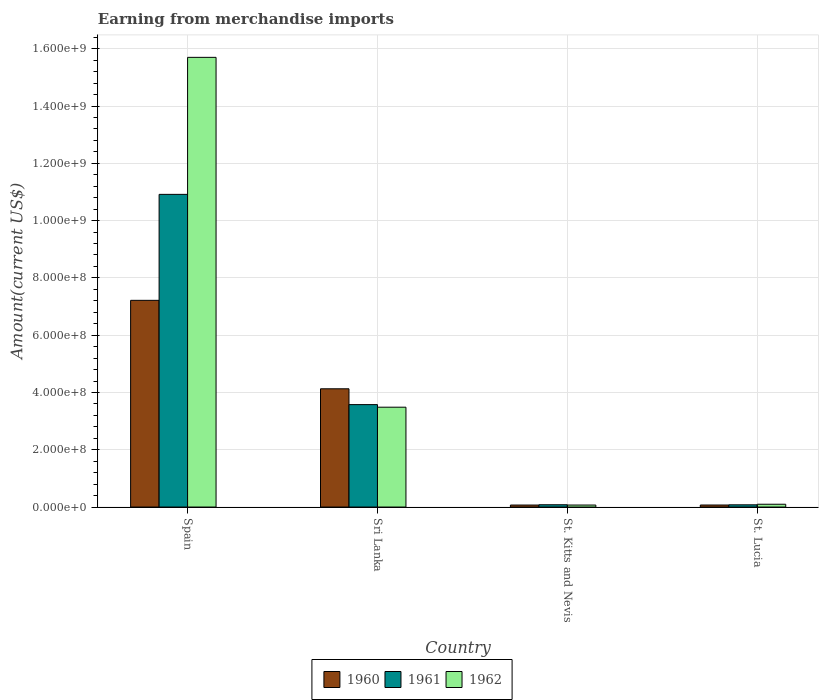How many different coloured bars are there?
Your response must be concise. 3. How many groups of bars are there?
Your answer should be compact. 4. Are the number of bars per tick equal to the number of legend labels?
Your answer should be compact. Yes. Are the number of bars on each tick of the X-axis equal?
Ensure brevity in your answer.  Yes. How many bars are there on the 4th tick from the left?
Your answer should be compact. 3. How many bars are there on the 2nd tick from the right?
Offer a very short reply. 3. What is the label of the 1st group of bars from the left?
Keep it short and to the point. Spain. In how many cases, is the number of bars for a given country not equal to the number of legend labels?
Your answer should be very brief. 0. What is the amount earned from merchandise imports in 1960 in St. Lucia?
Make the answer very short. 7.11e+06. Across all countries, what is the maximum amount earned from merchandise imports in 1960?
Offer a very short reply. 7.22e+08. Across all countries, what is the minimum amount earned from merchandise imports in 1961?
Your answer should be compact. 7.75e+06. In which country was the amount earned from merchandise imports in 1961 minimum?
Your answer should be compact. St. Lucia. What is the total amount earned from merchandise imports in 1961 in the graph?
Make the answer very short. 1.47e+09. What is the difference between the amount earned from merchandise imports in 1960 in Sri Lanka and that in St. Lucia?
Offer a terse response. 4.06e+08. What is the difference between the amount earned from merchandise imports in 1962 in St. Lucia and the amount earned from merchandise imports in 1961 in Sri Lanka?
Keep it short and to the point. -3.48e+08. What is the average amount earned from merchandise imports in 1961 per country?
Give a very brief answer. 3.66e+08. What is the difference between the amount earned from merchandise imports of/in 1961 and amount earned from merchandise imports of/in 1962 in Spain?
Offer a terse response. -4.78e+08. In how many countries, is the amount earned from merchandise imports in 1960 greater than 880000000 US$?
Offer a very short reply. 0. What is the ratio of the amount earned from merchandise imports in 1962 in Spain to that in St. Kitts and Nevis?
Keep it short and to the point. 224.29. Is the amount earned from merchandise imports in 1961 in St. Kitts and Nevis less than that in St. Lucia?
Your response must be concise. No. Is the difference between the amount earned from merchandise imports in 1961 in Sri Lanka and St. Kitts and Nevis greater than the difference between the amount earned from merchandise imports in 1962 in Sri Lanka and St. Kitts and Nevis?
Keep it short and to the point. Yes. What is the difference between the highest and the second highest amount earned from merchandise imports in 1960?
Your response must be concise. 7.15e+08. What is the difference between the highest and the lowest amount earned from merchandise imports in 1962?
Make the answer very short. 1.56e+09. In how many countries, is the amount earned from merchandise imports in 1962 greater than the average amount earned from merchandise imports in 1962 taken over all countries?
Offer a terse response. 1. Is the sum of the amount earned from merchandise imports in 1961 in Spain and Sri Lanka greater than the maximum amount earned from merchandise imports in 1962 across all countries?
Offer a terse response. No. What does the 1st bar from the left in St. Kitts and Nevis represents?
Your answer should be very brief. 1960. Is it the case that in every country, the sum of the amount earned from merchandise imports in 1961 and amount earned from merchandise imports in 1962 is greater than the amount earned from merchandise imports in 1960?
Keep it short and to the point. Yes. How many bars are there?
Your answer should be very brief. 12. How many countries are there in the graph?
Provide a succinct answer. 4. What is the difference between two consecutive major ticks on the Y-axis?
Give a very brief answer. 2.00e+08. Are the values on the major ticks of Y-axis written in scientific E-notation?
Provide a succinct answer. Yes. Does the graph contain any zero values?
Your answer should be compact. No. Where does the legend appear in the graph?
Keep it short and to the point. Bottom center. How many legend labels are there?
Make the answer very short. 3. What is the title of the graph?
Keep it short and to the point. Earning from merchandise imports. What is the label or title of the Y-axis?
Ensure brevity in your answer.  Amount(current US$). What is the Amount(current US$) in 1960 in Spain?
Ensure brevity in your answer.  7.22e+08. What is the Amount(current US$) of 1961 in Spain?
Provide a short and direct response. 1.09e+09. What is the Amount(current US$) in 1962 in Spain?
Your answer should be compact. 1.57e+09. What is the Amount(current US$) in 1960 in Sri Lanka?
Provide a short and direct response. 4.13e+08. What is the Amount(current US$) in 1961 in Sri Lanka?
Your answer should be very brief. 3.58e+08. What is the Amount(current US$) of 1962 in Sri Lanka?
Ensure brevity in your answer.  3.49e+08. What is the Amount(current US$) of 1960 in St. Kitts and Nevis?
Make the answer very short. 7.00e+06. What is the Amount(current US$) in 1962 in St. Kitts and Nevis?
Keep it short and to the point. 7.00e+06. What is the Amount(current US$) of 1960 in St. Lucia?
Provide a short and direct response. 7.11e+06. What is the Amount(current US$) in 1961 in St. Lucia?
Provide a short and direct response. 7.75e+06. What is the Amount(current US$) in 1962 in St. Lucia?
Keep it short and to the point. 9.77e+06. Across all countries, what is the maximum Amount(current US$) of 1960?
Give a very brief answer. 7.22e+08. Across all countries, what is the maximum Amount(current US$) in 1961?
Ensure brevity in your answer.  1.09e+09. Across all countries, what is the maximum Amount(current US$) of 1962?
Make the answer very short. 1.57e+09. Across all countries, what is the minimum Amount(current US$) of 1961?
Keep it short and to the point. 7.75e+06. Across all countries, what is the minimum Amount(current US$) in 1962?
Offer a terse response. 7.00e+06. What is the total Amount(current US$) in 1960 in the graph?
Offer a terse response. 1.15e+09. What is the total Amount(current US$) in 1961 in the graph?
Your answer should be compact. 1.47e+09. What is the total Amount(current US$) in 1962 in the graph?
Offer a terse response. 1.94e+09. What is the difference between the Amount(current US$) in 1960 in Spain and that in Sri Lanka?
Give a very brief answer. 3.09e+08. What is the difference between the Amount(current US$) of 1961 in Spain and that in Sri Lanka?
Provide a short and direct response. 7.34e+08. What is the difference between the Amount(current US$) of 1962 in Spain and that in Sri Lanka?
Your answer should be very brief. 1.22e+09. What is the difference between the Amount(current US$) in 1960 in Spain and that in St. Kitts and Nevis?
Provide a short and direct response. 7.15e+08. What is the difference between the Amount(current US$) of 1961 in Spain and that in St. Kitts and Nevis?
Your answer should be very brief. 1.08e+09. What is the difference between the Amount(current US$) in 1962 in Spain and that in St. Kitts and Nevis?
Provide a short and direct response. 1.56e+09. What is the difference between the Amount(current US$) in 1960 in Spain and that in St. Lucia?
Offer a very short reply. 7.15e+08. What is the difference between the Amount(current US$) in 1961 in Spain and that in St. Lucia?
Provide a succinct answer. 1.08e+09. What is the difference between the Amount(current US$) in 1962 in Spain and that in St. Lucia?
Provide a short and direct response. 1.56e+09. What is the difference between the Amount(current US$) in 1960 in Sri Lanka and that in St. Kitts and Nevis?
Ensure brevity in your answer.  4.06e+08. What is the difference between the Amount(current US$) in 1961 in Sri Lanka and that in St. Kitts and Nevis?
Offer a very short reply. 3.50e+08. What is the difference between the Amount(current US$) of 1962 in Sri Lanka and that in St. Kitts and Nevis?
Offer a very short reply. 3.42e+08. What is the difference between the Amount(current US$) in 1960 in Sri Lanka and that in St. Lucia?
Keep it short and to the point. 4.06e+08. What is the difference between the Amount(current US$) of 1961 in Sri Lanka and that in St. Lucia?
Keep it short and to the point. 3.50e+08. What is the difference between the Amount(current US$) in 1962 in Sri Lanka and that in St. Lucia?
Ensure brevity in your answer.  3.39e+08. What is the difference between the Amount(current US$) of 1960 in St. Kitts and Nevis and that in St. Lucia?
Make the answer very short. -1.07e+05. What is the difference between the Amount(current US$) of 1961 in St. Kitts and Nevis and that in St. Lucia?
Keep it short and to the point. 2.48e+05. What is the difference between the Amount(current US$) in 1962 in St. Kitts and Nevis and that in St. Lucia?
Your answer should be compact. -2.77e+06. What is the difference between the Amount(current US$) of 1960 in Spain and the Amount(current US$) of 1961 in Sri Lanka?
Keep it short and to the point. 3.64e+08. What is the difference between the Amount(current US$) of 1960 in Spain and the Amount(current US$) of 1962 in Sri Lanka?
Keep it short and to the point. 3.73e+08. What is the difference between the Amount(current US$) in 1961 in Spain and the Amount(current US$) in 1962 in Sri Lanka?
Your answer should be very brief. 7.43e+08. What is the difference between the Amount(current US$) of 1960 in Spain and the Amount(current US$) of 1961 in St. Kitts and Nevis?
Keep it short and to the point. 7.14e+08. What is the difference between the Amount(current US$) of 1960 in Spain and the Amount(current US$) of 1962 in St. Kitts and Nevis?
Ensure brevity in your answer.  7.15e+08. What is the difference between the Amount(current US$) of 1961 in Spain and the Amount(current US$) of 1962 in St. Kitts and Nevis?
Give a very brief answer. 1.08e+09. What is the difference between the Amount(current US$) in 1960 in Spain and the Amount(current US$) in 1961 in St. Lucia?
Your answer should be compact. 7.14e+08. What is the difference between the Amount(current US$) of 1960 in Spain and the Amount(current US$) of 1962 in St. Lucia?
Your answer should be compact. 7.12e+08. What is the difference between the Amount(current US$) of 1961 in Spain and the Amount(current US$) of 1962 in St. Lucia?
Provide a succinct answer. 1.08e+09. What is the difference between the Amount(current US$) of 1960 in Sri Lanka and the Amount(current US$) of 1961 in St. Kitts and Nevis?
Provide a short and direct response. 4.05e+08. What is the difference between the Amount(current US$) in 1960 in Sri Lanka and the Amount(current US$) in 1962 in St. Kitts and Nevis?
Offer a very short reply. 4.06e+08. What is the difference between the Amount(current US$) of 1961 in Sri Lanka and the Amount(current US$) of 1962 in St. Kitts and Nevis?
Your response must be concise. 3.51e+08. What is the difference between the Amount(current US$) in 1960 in Sri Lanka and the Amount(current US$) in 1961 in St. Lucia?
Offer a terse response. 4.05e+08. What is the difference between the Amount(current US$) of 1960 in Sri Lanka and the Amount(current US$) of 1962 in St. Lucia?
Provide a succinct answer. 4.03e+08. What is the difference between the Amount(current US$) of 1961 in Sri Lanka and the Amount(current US$) of 1962 in St. Lucia?
Your answer should be compact. 3.48e+08. What is the difference between the Amount(current US$) of 1960 in St. Kitts and Nevis and the Amount(current US$) of 1961 in St. Lucia?
Provide a succinct answer. -7.52e+05. What is the difference between the Amount(current US$) in 1960 in St. Kitts and Nevis and the Amount(current US$) in 1962 in St. Lucia?
Keep it short and to the point. -2.77e+06. What is the difference between the Amount(current US$) of 1961 in St. Kitts and Nevis and the Amount(current US$) of 1962 in St. Lucia?
Provide a succinct answer. -1.77e+06. What is the average Amount(current US$) in 1960 per country?
Your response must be concise. 2.87e+08. What is the average Amount(current US$) in 1961 per country?
Your response must be concise. 3.66e+08. What is the average Amount(current US$) of 1962 per country?
Ensure brevity in your answer.  4.84e+08. What is the difference between the Amount(current US$) in 1960 and Amount(current US$) in 1961 in Spain?
Give a very brief answer. -3.70e+08. What is the difference between the Amount(current US$) in 1960 and Amount(current US$) in 1962 in Spain?
Offer a terse response. -8.48e+08. What is the difference between the Amount(current US$) in 1961 and Amount(current US$) in 1962 in Spain?
Give a very brief answer. -4.78e+08. What is the difference between the Amount(current US$) of 1960 and Amount(current US$) of 1961 in Sri Lanka?
Offer a terse response. 5.52e+07. What is the difference between the Amount(current US$) in 1960 and Amount(current US$) in 1962 in Sri Lanka?
Make the answer very short. 6.43e+07. What is the difference between the Amount(current US$) of 1961 and Amount(current US$) of 1962 in Sri Lanka?
Give a very brief answer. 9.03e+06. What is the difference between the Amount(current US$) of 1961 and Amount(current US$) of 1962 in St. Kitts and Nevis?
Make the answer very short. 1.00e+06. What is the difference between the Amount(current US$) of 1960 and Amount(current US$) of 1961 in St. Lucia?
Make the answer very short. -6.46e+05. What is the difference between the Amount(current US$) in 1960 and Amount(current US$) in 1962 in St. Lucia?
Provide a succinct answer. -2.66e+06. What is the difference between the Amount(current US$) in 1961 and Amount(current US$) in 1962 in St. Lucia?
Give a very brief answer. -2.02e+06. What is the ratio of the Amount(current US$) of 1960 in Spain to that in Sri Lanka?
Ensure brevity in your answer.  1.75. What is the ratio of the Amount(current US$) in 1961 in Spain to that in Sri Lanka?
Your answer should be very brief. 3.05. What is the ratio of the Amount(current US$) of 1962 in Spain to that in Sri Lanka?
Offer a very short reply. 4.5. What is the ratio of the Amount(current US$) in 1960 in Spain to that in St. Kitts and Nevis?
Keep it short and to the point. 103.1. What is the ratio of the Amount(current US$) in 1961 in Spain to that in St. Kitts and Nevis?
Your response must be concise. 136.46. What is the ratio of the Amount(current US$) in 1962 in Spain to that in St. Kitts and Nevis?
Ensure brevity in your answer.  224.29. What is the ratio of the Amount(current US$) of 1960 in Spain to that in St. Lucia?
Offer a very short reply. 101.55. What is the ratio of the Amount(current US$) in 1961 in Spain to that in St. Lucia?
Make the answer very short. 140.82. What is the ratio of the Amount(current US$) of 1962 in Spain to that in St. Lucia?
Ensure brevity in your answer.  160.72. What is the ratio of the Amount(current US$) in 1960 in Sri Lanka to that in St. Kitts and Nevis?
Offer a very short reply. 58.98. What is the ratio of the Amount(current US$) of 1961 in Sri Lanka to that in St. Kitts and Nevis?
Offer a very short reply. 44.7. What is the ratio of the Amount(current US$) in 1962 in Sri Lanka to that in St. Kitts and Nevis?
Your answer should be compact. 49.8. What is the ratio of the Amount(current US$) of 1960 in Sri Lanka to that in St. Lucia?
Your answer should be very brief. 58.09. What is the ratio of the Amount(current US$) in 1961 in Sri Lanka to that in St. Lucia?
Provide a short and direct response. 46.13. What is the ratio of the Amount(current US$) of 1962 in Sri Lanka to that in St. Lucia?
Keep it short and to the point. 35.69. What is the ratio of the Amount(current US$) of 1960 in St. Kitts and Nevis to that in St. Lucia?
Make the answer very short. 0.98. What is the ratio of the Amount(current US$) in 1961 in St. Kitts and Nevis to that in St. Lucia?
Make the answer very short. 1.03. What is the ratio of the Amount(current US$) of 1962 in St. Kitts and Nevis to that in St. Lucia?
Ensure brevity in your answer.  0.72. What is the difference between the highest and the second highest Amount(current US$) in 1960?
Provide a short and direct response. 3.09e+08. What is the difference between the highest and the second highest Amount(current US$) in 1961?
Your answer should be compact. 7.34e+08. What is the difference between the highest and the second highest Amount(current US$) in 1962?
Provide a succinct answer. 1.22e+09. What is the difference between the highest and the lowest Amount(current US$) of 1960?
Provide a short and direct response. 7.15e+08. What is the difference between the highest and the lowest Amount(current US$) in 1961?
Offer a very short reply. 1.08e+09. What is the difference between the highest and the lowest Amount(current US$) in 1962?
Your response must be concise. 1.56e+09. 